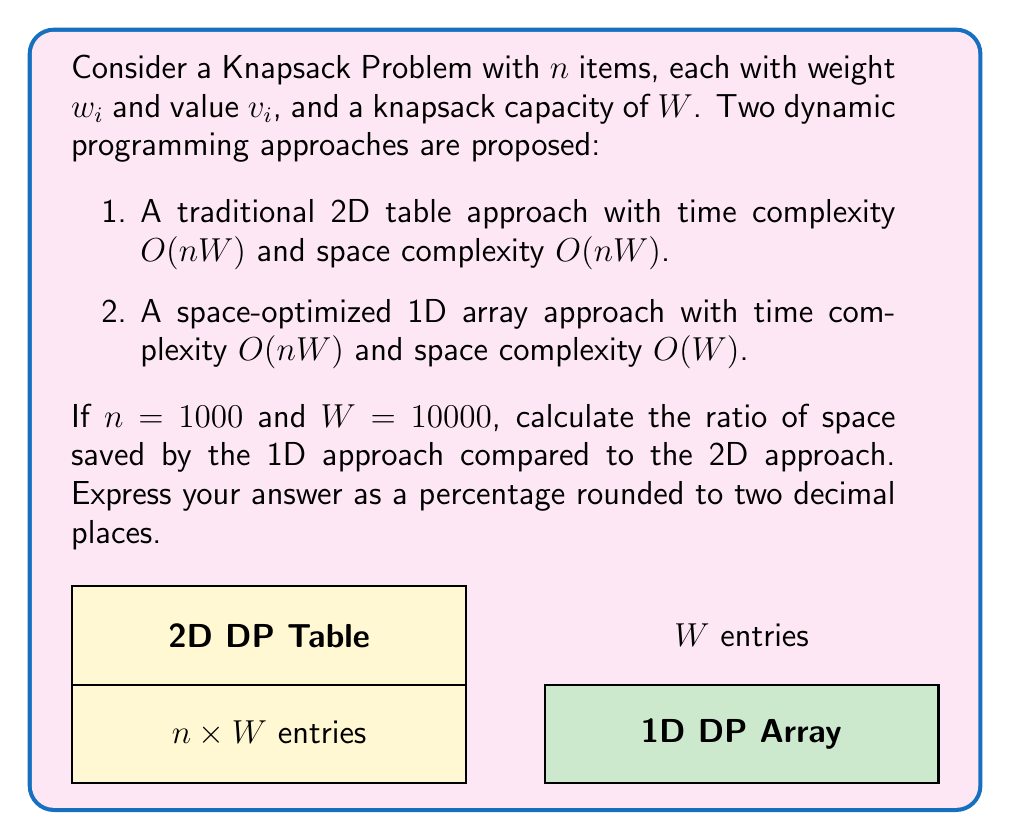What is the answer to this math problem? Let's approach this step-by-step:

1) First, let's calculate the space required for each approach:

   2D approach: $O(nW) = 1000 \times 10000 = 10,000,000$ entries
   1D approach: $O(W) = 10000$ entries

2) Now, let's calculate the difference in space:

   Space saved = $10,000,000 - 10,000 = 9,990,000$ entries

3) To express this as a ratio, we divide the space saved by the original space:

   Ratio = $\frac{9,990,000}{10,000,000} = 0.999$

4) To convert to a percentage, we multiply by 100:

   Percentage = $0.999 \times 100 = 99.9\%$

5) Rounding to two decimal places gives us 99.90%.

Therefore, the 1D approach saves 99.90% of the space compared to the 2D approach.
Answer: 99.90% 